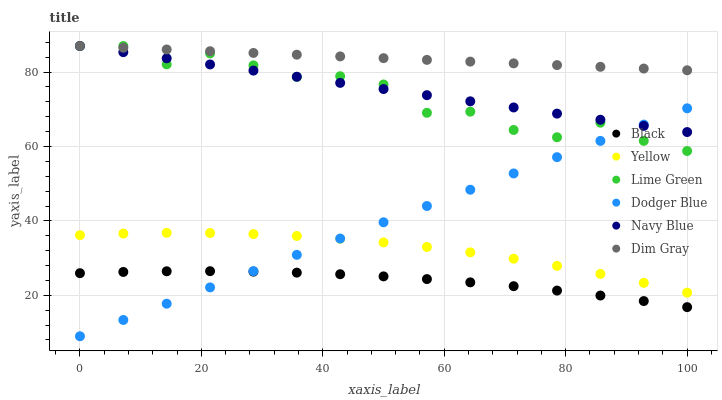Does Black have the minimum area under the curve?
Answer yes or no. Yes. Does Dim Gray have the maximum area under the curve?
Answer yes or no. Yes. Does Navy Blue have the minimum area under the curve?
Answer yes or no. No. Does Navy Blue have the maximum area under the curve?
Answer yes or no. No. Is Dodger Blue the smoothest?
Answer yes or no. Yes. Is Lime Green the roughest?
Answer yes or no. Yes. Is Navy Blue the smoothest?
Answer yes or no. No. Is Navy Blue the roughest?
Answer yes or no. No. Does Dodger Blue have the lowest value?
Answer yes or no. Yes. Does Navy Blue have the lowest value?
Answer yes or no. No. Does Lime Green have the highest value?
Answer yes or no. Yes. Does Yellow have the highest value?
Answer yes or no. No. Is Black less than Navy Blue?
Answer yes or no. Yes. Is Dim Gray greater than Dodger Blue?
Answer yes or no. Yes. Does Dim Gray intersect Lime Green?
Answer yes or no. Yes. Is Dim Gray less than Lime Green?
Answer yes or no. No. Is Dim Gray greater than Lime Green?
Answer yes or no. No. Does Black intersect Navy Blue?
Answer yes or no. No. 